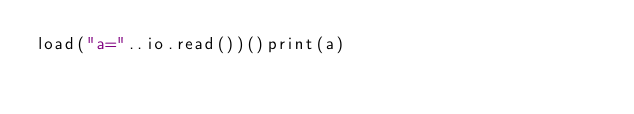Convert code to text. <code><loc_0><loc_0><loc_500><loc_500><_Lua_>load("a="..io.read())()print(a)</code> 